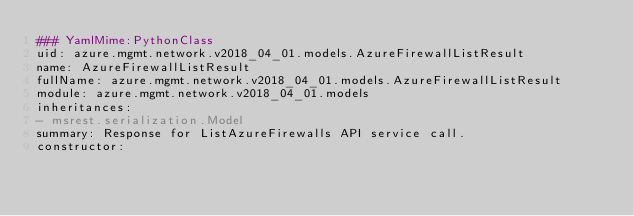Convert code to text. <code><loc_0><loc_0><loc_500><loc_500><_YAML_>### YamlMime:PythonClass
uid: azure.mgmt.network.v2018_04_01.models.AzureFirewallListResult
name: AzureFirewallListResult
fullName: azure.mgmt.network.v2018_04_01.models.AzureFirewallListResult
module: azure.mgmt.network.v2018_04_01.models
inheritances:
- msrest.serialization.Model
summary: Response for ListAzureFirewalls API service call.
constructor:</code> 